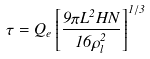<formula> <loc_0><loc_0><loc_500><loc_500>\tau = Q _ { e } \left [ { \frac { 9 \pi L ^ { 2 } H N } { 1 6 \rho _ { l } ^ { 2 } } } \right ] ^ { 1 / 3 }</formula> 